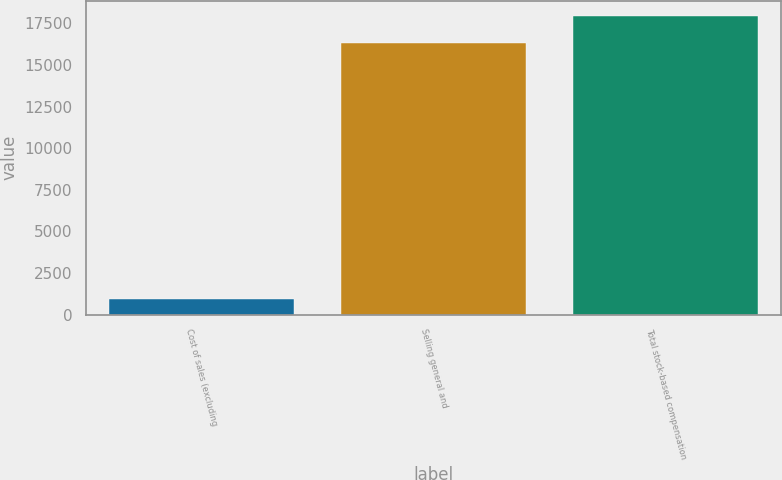<chart> <loc_0><loc_0><loc_500><loc_500><bar_chart><fcel>Cost of sales (excluding<fcel>Selling general and<fcel>Total stock-based compensation<nl><fcel>914<fcel>16336<fcel>17969.6<nl></chart> 